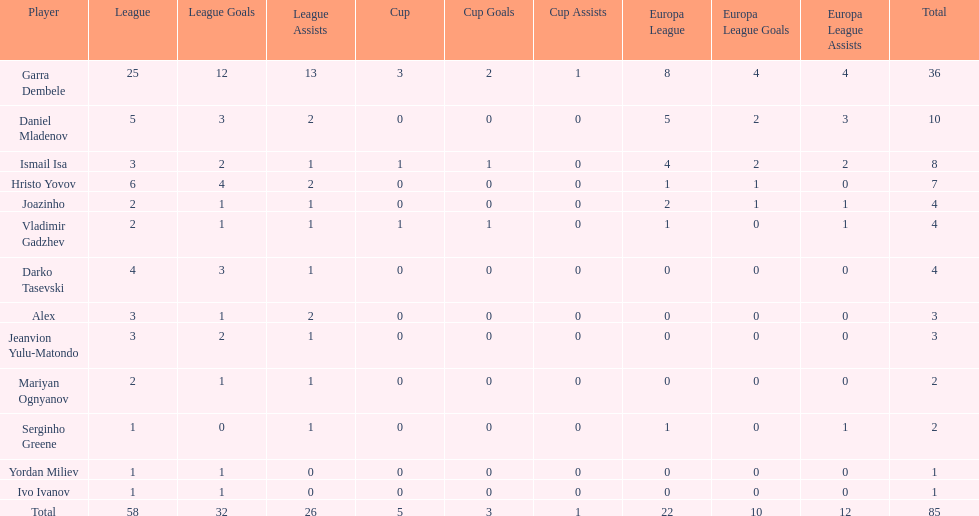Can you provide the count of goals ismail isa has scored during this season? 8. 